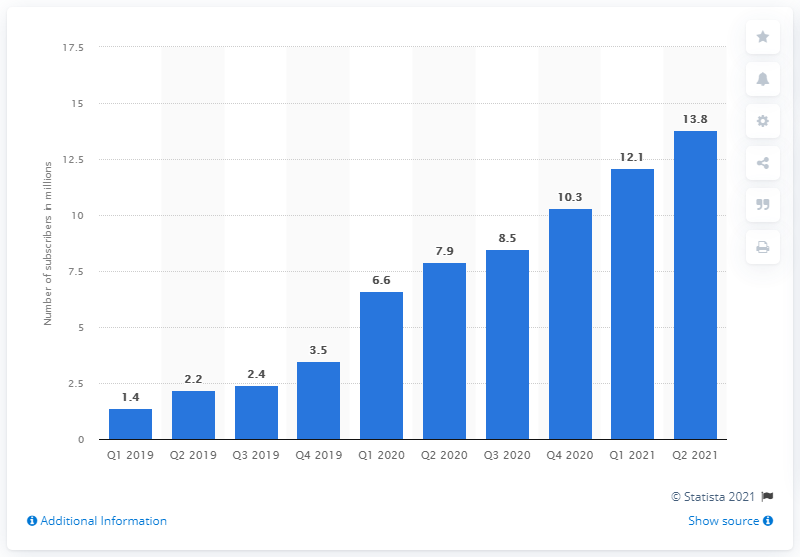List a handful of essential elements in this visual. At the end of ESPN+'s first fiscal quarter of 2019, the platform had 1.4 subscribers. 